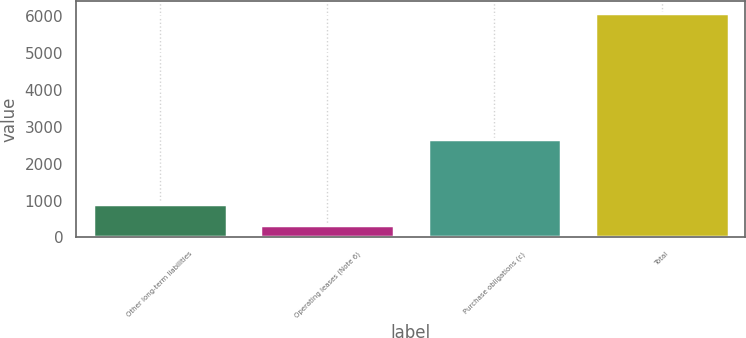Convert chart. <chart><loc_0><loc_0><loc_500><loc_500><bar_chart><fcel>Other long-term liabilities<fcel>Operating leases (Note 6)<fcel>Purchase obligations (c)<fcel>Total<nl><fcel>907.5<fcel>330<fcel>2684<fcel>6105<nl></chart> 